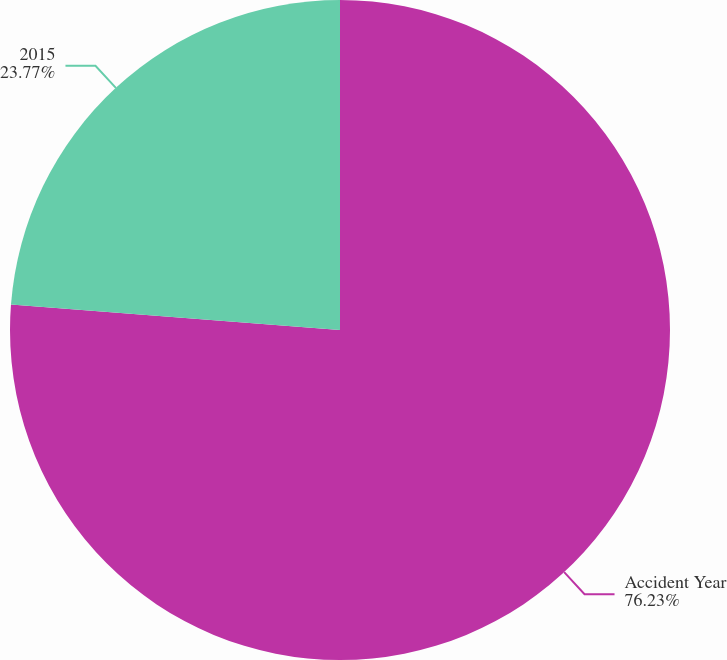Convert chart to OTSL. <chart><loc_0><loc_0><loc_500><loc_500><pie_chart><fcel>Accident Year<fcel>2015<nl><fcel>76.23%<fcel>23.77%<nl></chart> 